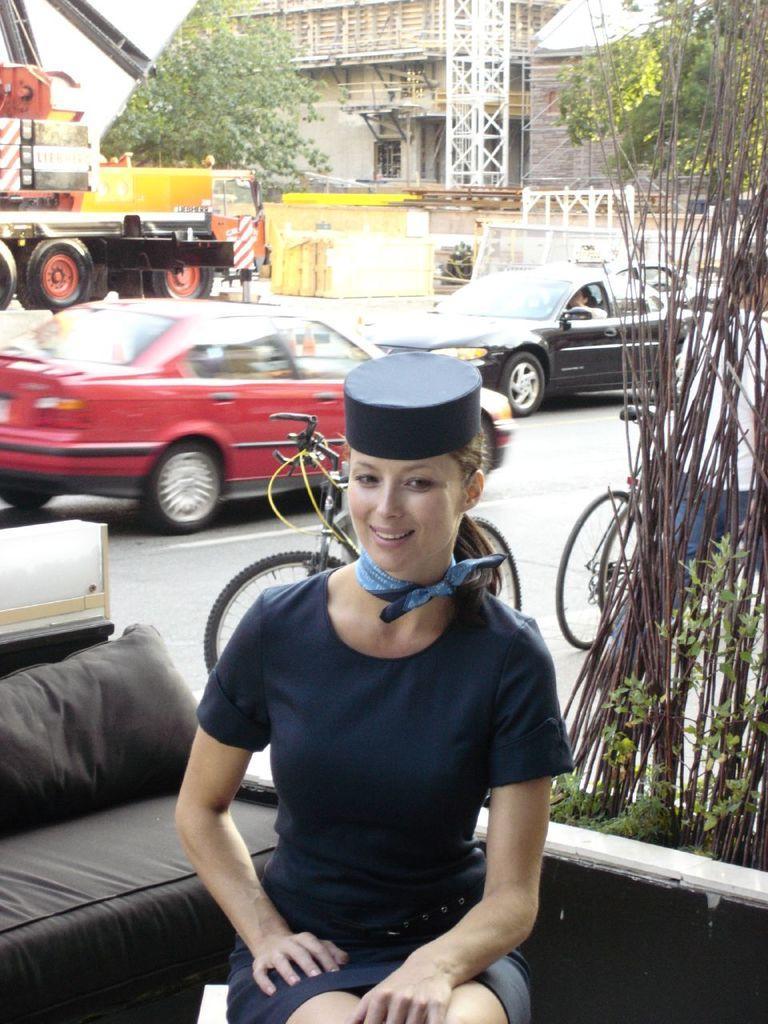Describe this image in one or two sentences. In this image there is a girl sitting in the sofa near the plants, behind her there is a road where so many cars and bicycles riding on it, also there is a building and crane with some things in it. 